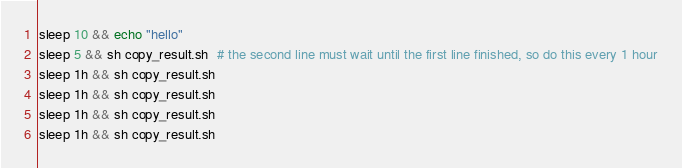Convert code to text. <code><loc_0><loc_0><loc_500><loc_500><_Bash_>sleep 10 && echo "hello"
sleep 5 && sh copy_result.sh  # the second line must wait until the first line finished, so do this every 1 hour
sleep 1h && sh copy_result.sh
sleep 1h && sh copy_result.sh
sleep 1h && sh copy_result.sh
sleep 1h && sh copy_result.sh
</code> 